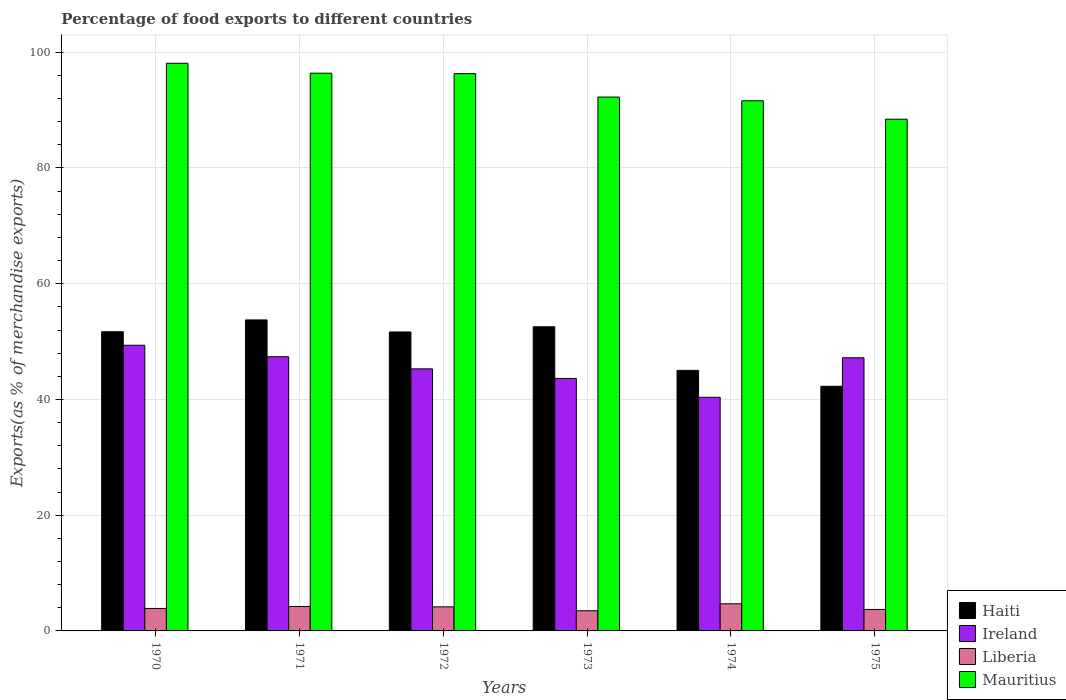How many groups of bars are there?
Offer a very short reply. 6. How many bars are there on the 2nd tick from the left?
Your answer should be compact. 4. How many bars are there on the 5th tick from the right?
Give a very brief answer. 4. What is the label of the 5th group of bars from the left?
Ensure brevity in your answer.  1974. What is the percentage of exports to different countries in Liberia in 1973?
Your response must be concise. 3.49. Across all years, what is the maximum percentage of exports to different countries in Mauritius?
Provide a short and direct response. 98.1. Across all years, what is the minimum percentage of exports to different countries in Ireland?
Your response must be concise. 40.37. In which year was the percentage of exports to different countries in Haiti maximum?
Your answer should be very brief. 1971. In which year was the percentage of exports to different countries in Mauritius minimum?
Offer a very short reply. 1975. What is the total percentage of exports to different countries in Ireland in the graph?
Ensure brevity in your answer.  273.23. What is the difference between the percentage of exports to different countries in Haiti in 1971 and that in 1974?
Give a very brief answer. 8.72. What is the difference between the percentage of exports to different countries in Mauritius in 1975 and the percentage of exports to different countries in Ireland in 1974?
Keep it short and to the point. 48.06. What is the average percentage of exports to different countries in Liberia per year?
Keep it short and to the point. 4.03. In the year 1975, what is the difference between the percentage of exports to different countries in Mauritius and percentage of exports to different countries in Liberia?
Your response must be concise. 84.72. What is the ratio of the percentage of exports to different countries in Haiti in 1971 to that in 1972?
Keep it short and to the point. 1.04. Is the percentage of exports to different countries in Liberia in 1970 less than that in 1972?
Provide a short and direct response. Yes. What is the difference between the highest and the second highest percentage of exports to different countries in Liberia?
Ensure brevity in your answer.  0.46. What is the difference between the highest and the lowest percentage of exports to different countries in Ireland?
Your response must be concise. 9. In how many years, is the percentage of exports to different countries in Liberia greater than the average percentage of exports to different countries in Liberia taken over all years?
Provide a succinct answer. 3. Is the sum of the percentage of exports to different countries in Liberia in 1971 and 1972 greater than the maximum percentage of exports to different countries in Mauritius across all years?
Offer a very short reply. No. What does the 3rd bar from the left in 1972 represents?
Offer a terse response. Liberia. What does the 2nd bar from the right in 1974 represents?
Offer a very short reply. Liberia. How many bars are there?
Your answer should be compact. 24. Are all the bars in the graph horizontal?
Keep it short and to the point. No. Are the values on the major ticks of Y-axis written in scientific E-notation?
Your answer should be very brief. No. Does the graph contain grids?
Provide a succinct answer. Yes. What is the title of the graph?
Offer a very short reply. Percentage of food exports to different countries. What is the label or title of the Y-axis?
Ensure brevity in your answer.  Exports(as % of merchandise exports). What is the Exports(as % of merchandise exports) in Haiti in 1970?
Your response must be concise. 51.71. What is the Exports(as % of merchandise exports) in Ireland in 1970?
Provide a short and direct response. 49.37. What is the Exports(as % of merchandise exports) in Liberia in 1970?
Ensure brevity in your answer.  3.88. What is the Exports(as % of merchandise exports) in Mauritius in 1970?
Offer a terse response. 98.1. What is the Exports(as % of merchandise exports) of Haiti in 1971?
Ensure brevity in your answer.  53.74. What is the Exports(as % of merchandise exports) in Ireland in 1971?
Offer a very short reply. 47.38. What is the Exports(as % of merchandise exports) in Liberia in 1971?
Ensure brevity in your answer.  4.22. What is the Exports(as % of merchandise exports) in Mauritius in 1971?
Offer a terse response. 96.38. What is the Exports(as % of merchandise exports) of Haiti in 1972?
Your response must be concise. 51.66. What is the Exports(as % of merchandise exports) in Ireland in 1972?
Offer a terse response. 45.29. What is the Exports(as % of merchandise exports) in Liberia in 1972?
Keep it short and to the point. 4.16. What is the Exports(as % of merchandise exports) in Mauritius in 1972?
Ensure brevity in your answer.  96.3. What is the Exports(as % of merchandise exports) in Haiti in 1973?
Offer a very short reply. 52.56. What is the Exports(as % of merchandise exports) of Ireland in 1973?
Provide a succinct answer. 43.63. What is the Exports(as % of merchandise exports) in Liberia in 1973?
Offer a very short reply. 3.49. What is the Exports(as % of merchandise exports) of Mauritius in 1973?
Provide a short and direct response. 92.26. What is the Exports(as % of merchandise exports) in Haiti in 1974?
Keep it short and to the point. 45.02. What is the Exports(as % of merchandise exports) of Ireland in 1974?
Your answer should be very brief. 40.37. What is the Exports(as % of merchandise exports) in Liberia in 1974?
Keep it short and to the point. 4.69. What is the Exports(as % of merchandise exports) of Mauritius in 1974?
Offer a terse response. 91.61. What is the Exports(as % of merchandise exports) of Haiti in 1975?
Provide a short and direct response. 42.28. What is the Exports(as % of merchandise exports) in Ireland in 1975?
Your answer should be very brief. 47.2. What is the Exports(as % of merchandise exports) in Liberia in 1975?
Offer a terse response. 3.71. What is the Exports(as % of merchandise exports) in Mauritius in 1975?
Keep it short and to the point. 88.43. Across all years, what is the maximum Exports(as % of merchandise exports) in Haiti?
Offer a terse response. 53.74. Across all years, what is the maximum Exports(as % of merchandise exports) in Ireland?
Offer a terse response. 49.37. Across all years, what is the maximum Exports(as % of merchandise exports) of Liberia?
Your response must be concise. 4.69. Across all years, what is the maximum Exports(as % of merchandise exports) in Mauritius?
Your response must be concise. 98.1. Across all years, what is the minimum Exports(as % of merchandise exports) of Haiti?
Make the answer very short. 42.28. Across all years, what is the minimum Exports(as % of merchandise exports) in Ireland?
Provide a succinct answer. 40.37. Across all years, what is the minimum Exports(as % of merchandise exports) of Liberia?
Offer a terse response. 3.49. Across all years, what is the minimum Exports(as % of merchandise exports) of Mauritius?
Keep it short and to the point. 88.43. What is the total Exports(as % of merchandise exports) of Haiti in the graph?
Your answer should be compact. 296.97. What is the total Exports(as % of merchandise exports) of Ireland in the graph?
Make the answer very short. 273.23. What is the total Exports(as % of merchandise exports) of Liberia in the graph?
Ensure brevity in your answer.  24.15. What is the total Exports(as % of merchandise exports) of Mauritius in the graph?
Give a very brief answer. 563.09. What is the difference between the Exports(as % of merchandise exports) of Haiti in 1970 and that in 1971?
Ensure brevity in your answer.  -2.04. What is the difference between the Exports(as % of merchandise exports) of Ireland in 1970 and that in 1971?
Provide a succinct answer. 1.99. What is the difference between the Exports(as % of merchandise exports) in Liberia in 1970 and that in 1971?
Your response must be concise. -0.34. What is the difference between the Exports(as % of merchandise exports) of Mauritius in 1970 and that in 1971?
Your answer should be compact. 1.72. What is the difference between the Exports(as % of merchandise exports) of Haiti in 1970 and that in 1972?
Keep it short and to the point. 0.04. What is the difference between the Exports(as % of merchandise exports) in Ireland in 1970 and that in 1972?
Keep it short and to the point. 4.08. What is the difference between the Exports(as % of merchandise exports) in Liberia in 1970 and that in 1972?
Your response must be concise. -0.27. What is the difference between the Exports(as % of merchandise exports) in Mauritius in 1970 and that in 1972?
Ensure brevity in your answer.  1.79. What is the difference between the Exports(as % of merchandise exports) of Haiti in 1970 and that in 1973?
Your response must be concise. -0.85. What is the difference between the Exports(as % of merchandise exports) of Ireland in 1970 and that in 1973?
Your answer should be compact. 5.74. What is the difference between the Exports(as % of merchandise exports) in Liberia in 1970 and that in 1973?
Offer a terse response. 0.4. What is the difference between the Exports(as % of merchandise exports) of Mauritius in 1970 and that in 1973?
Your answer should be very brief. 5.84. What is the difference between the Exports(as % of merchandise exports) of Haiti in 1970 and that in 1974?
Your response must be concise. 6.68. What is the difference between the Exports(as % of merchandise exports) of Ireland in 1970 and that in 1974?
Ensure brevity in your answer.  9. What is the difference between the Exports(as % of merchandise exports) of Liberia in 1970 and that in 1974?
Give a very brief answer. -0.8. What is the difference between the Exports(as % of merchandise exports) of Mauritius in 1970 and that in 1974?
Keep it short and to the point. 6.49. What is the difference between the Exports(as % of merchandise exports) of Haiti in 1970 and that in 1975?
Ensure brevity in your answer.  9.43. What is the difference between the Exports(as % of merchandise exports) in Ireland in 1970 and that in 1975?
Offer a very short reply. 2.17. What is the difference between the Exports(as % of merchandise exports) in Liberia in 1970 and that in 1975?
Your answer should be very brief. 0.17. What is the difference between the Exports(as % of merchandise exports) in Mauritius in 1970 and that in 1975?
Ensure brevity in your answer.  9.67. What is the difference between the Exports(as % of merchandise exports) of Haiti in 1971 and that in 1972?
Ensure brevity in your answer.  2.08. What is the difference between the Exports(as % of merchandise exports) in Ireland in 1971 and that in 1972?
Your answer should be compact. 2.09. What is the difference between the Exports(as % of merchandise exports) of Liberia in 1971 and that in 1972?
Your answer should be very brief. 0.07. What is the difference between the Exports(as % of merchandise exports) of Mauritius in 1971 and that in 1972?
Offer a very short reply. 0.08. What is the difference between the Exports(as % of merchandise exports) of Haiti in 1971 and that in 1973?
Ensure brevity in your answer.  1.18. What is the difference between the Exports(as % of merchandise exports) in Ireland in 1971 and that in 1973?
Provide a succinct answer. 3.75. What is the difference between the Exports(as % of merchandise exports) in Liberia in 1971 and that in 1973?
Provide a short and direct response. 0.74. What is the difference between the Exports(as % of merchandise exports) in Mauritius in 1971 and that in 1973?
Your answer should be very brief. 4.12. What is the difference between the Exports(as % of merchandise exports) in Haiti in 1971 and that in 1974?
Your answer should be compact. 8.72. What is the difference between the Exports(as % of merchandise exports) in Ireland in 1971 and that in 1974?
Your answer should be very brief. 7. What is the difference between the Exports(as % of merchandise exports) of Liberia in 1971 and that in 1974?
Your answer should be very brief. -0.46. What is the difference between the Exports(as % of merchandise exports) in Mauritius in 1971 and that in 1974?
Offer a terse response. 4.77. What is the difference between the Exports(as % of merchandise exports) in Haiti in 1971 and that in 1975?
Keep it short and to the point. 11.46. What is the difference between the Exports(as % of merchandise exports) of Ireland in 1971 and that in 1975?
Your response must be concise. 0.18. What is the difference between the Exports(as % of merchandise exports) of Liberia in 1971 and that in 1975?
Ensure brevity in your answer.  0.51. What is the difference between the Exports(as % of merchandise exports) of Mauritius in 1971 and that in 1975?
Keep it short and to the point. 7.95. What is the difference between the Exports(as % of merchandise exports) of Haiti in 1972 and that in 1973?
Provide a short and direct response. -0.89. What is the difference between the Exports(as % of merchandise exports) in Ireland in 1972 and that in 1973?
Your answer should be very brief. 1.66. What is the difference between the Exports(as % of merchandise exports) of Liberia in 1972 and that in 1973?
Offer a very short reply. 0.67. What is the difference between the Exports(as % of merchandise exports) of Mauritius in 1972 and that in 1973?
Your answer should be very brief. 4.05. What is the difference between the Exports(as % of merchandise exports) of Haiti in 1972 and that in 1974?
Ensure brevity in your answer.  6.64. What is the difference between the Exports(as % of merchandise exports) of Ireland in 1972 and that in 1974?
Make the answer very short. 4.91. What is the difference between the Exports(as % of merchandise exports) in Liberia in 1972 and that in 1974?
Provide a succinct answer. -0.53. What is the difference between the Exports(as % of merchandise exports) of Mauritius in 1972 and that in 1974?
Offer a terse response. 4.69. What is the difference between the Exports(as % of merchandise exports) of Haiti in 1972 and that in 1975?
Your answer should be compact. 9.39. What is the difference between the Exports(as % of merchandise exports) in Ireland in 1972 and that in 1975?
Provide a succinct answer. -1.91. What is the difference between the Exports(as % of merchandise exports) in Liberia in 1972 and that in 1975?
Keep it short and to the point. 0.45. What is the difference between the Exports(as % of merchandise exports) in Mauritius in 1972 and that in 1975?
Provide a succinct answer. 7.87. What is the difference between the Exports(as % of merchandise exports) of Haiti in 1973 and that in 1974?
Give a very brief answer. 7.53. What is the difference between the Exports(as % of merchandise exports) of Ireland in 1973 and that in 1974?
Give a very brief answer. 3.25. What is the difference between the Exports(as % of merchandise exports) in Liberia in 1973 and that in 1974?
Provide a short and direct response. -1.2. What is the difference between the Exports(as % of merchandise exports) of Mauritius in 1973 and that in 1974?
Ensure brevity in your answer.  0.65. What is the difference between the Exports(as % of merchandise exports) of Haiti in 1973 and that in 1975?
Your answer should be very brief. 10.28. What is the difference between the Exports(as % of merchandise exports) in Ireland in 1973 and that in 1975?
Give a very brief answer. -3.57. What is the difference between the Exports(as % of merchandise exports) in Liberia in 1973 and that in 1975?
Your response must be concise. -0.22. What is the difference between the Exports(as % of merchandise exports) of Mauritius in 1973 and that in 1975?
Provide a succinct answer. 3.83. What is the difference between the Exports(as % of merchandise exports) of Haiti in 1974 and that in 1975?
Offer a very short reply. 2.75. What is the difference between the Exports(as % of merchandise exports) in Ireland in 1974 and that in 1975?
Provide a short and direct response. -6.83. What is the difference between the Exports(as % of merchandise exports) of Liberia in 1974 and that in 1975?
Your answer should be very brief. 0.97. What is the difference between the Exports(as % of merchandise exports) in Mauritius in 1974 and that in 1975?
Ensure brevity in your answer.  3.18. What is the difference between the Exports(as % of merchandise exports) in Haiti in 1970 and the Exports(as % of merchandise exports) in Ireland in 1971?
Your response must be concise. 4.33. What is the difference between the Exports(as % of merchandise exports) of Haiti in 1970 and the Exports(as % of merchandise exports) of Liberia in 1971?
Your response must be concise. 47.48. What is the difference between the Exports(as % of merchandise exports) in Haiti in 1970 and the Exports(as % of merchandise exports) in Mauritius in 1971?
Provide a succinct answer. -44.68. What is the difference between the Exports(as % of merchandise exports) of Ireland in 1970 and the Exports(as % of merchandise exports) of Liberia in 1971?
Your answer should be compact. 45.14. What is the difference between the Exports(as % of merchandise exports) of Ireland in 1970 and the Exports(as % of merchandise exports) of Mauritius in 1971?
Ensure brevity in your answer.  -47.01. What is the difference between the Exports(as % of merchandise exports) of Liberia in 1970 and the Exports(as % of merchandise exports) of Mauritius in 1971?
Make the answer very short. -92.5. What is the difference between the Exports(as % of merchandise exports) in Haiti in 1970 and the Exports(as % of merchandise exports) in Ireland in 1972?
Keep it short and to the point. 6.42. What is the difference between the Exports(as % of merchandise exports) of Haiti in 1970 and the Exports(as % of merchandise exports) of Liberia in 1972?
Keep it short and to the point. 47.55. What is the difference between the Exports(as % of merchandise exports) of Haiti in 1970 and the Exports(as % of merchandise exports) of Mauritius in 1972?
Offer a very short reply. -44.6. What is the difference between the Exports(as % of merchandise exports) in Ireland in 1970 and the Exports(as % of merchandise exports) in Liberia in 1972?
Provide a succinct answer. 45.21. What is the difference between the Exports(as % of merchandise exports) in Ireland in 1970 and the Exports(as % of merchandise exports) in Mauritius in 1972?
Offer a terse response. -46.94. What is the difference between the Exports(as % of merchandise exports) of Liberia in 1970 and the Exports(as % of merchandise exports) of Mauritius in 1972?
Offer a terse response. -92.42. What is the difference between the Exports(as % of merchandise exports) of Haiti in 1970 and the Exports(as % of merchandise exports) of Ireland in 1973?
Keep it short and to the point. 8.08. What is the difference between the Exports(as % of merchandise exports) in Haiti in 1970 and the Exports(as % of merchandise exports) in Liberia in 1973?
Ensure brevity in your answer.  48.22. What is the difference between the Exports(as % of merchandise exports) of Haiti in 1970 and the Exports(as % of merchandise exports) of Mauritius in 1973?
Your response must be concise. -40.55. What is the difference between the Exports(as % of merchandise exports) in Ireland in 1970 and the Exports(as % of merchandise exports) in Liberia in 1973?
Keep it short and to the point. 45.88. What is the difference between the Exports(as % of merchandise exports) in Ireland in 1970 and the Exports(as % of merchandise exports) in Mauritius in 1973?
Offer a very short reply. -42.89. What is the difference between the Exports(as % of merchandise exports) in Liberia in 1970 and the Exports(as % of merchandise exports) in Mauritius in 1973?
Your answer should be compact. -88.37. What is the difference between the Exports(as % of merchandise exports) of Haiti in 1970 and the Exports(as % of merchandise exports) of Ireland in 1974?
Offer a terse response. 11.33. What is the difference between the Exports(as % of merchandise exports) in Haiti in 1970 and the Exports(as % of merchandise exports) in Liberia in 1974?
Provide a succinct answer. 47.02. What is the difference between the Exports(as % of merchandise exports) of Haiti in 1970 and the Exports(as % of merchandise exports) of Mauritius in 1974?
Offer a terse response. -39.91. What is the difference between the Exports(as % of merchandise exports) of Ireland in 1970 and the Exports(as % of merchandise exports) of Liberia in 1974?
Your answer should be compact. 44.68. What is the difference between the Exports(as % of merchandise exports) in Ireland in 1970 and the Exports(as % of merchandise exports) in Mauritius in 1974?
Your response must be concise. -42.25. What is the difference between the Exports(as % of merchandise exports) of Liberia in 1970 and the Exports(as % of merchandise exports) of Mauritius in 1974?
Make the answer very short. -87.73. What is the difference between the Exports(as % of merchandise exports) of Haiti in 1970 and the Exports(as % of merchandise exports) of Ireland in 1975?
Provide a succinct answer. 4.51. What is the difference between the Exports(as % of merchandise exports) in Haiti in 1970 and the Exports(as % of merchandise exports) in Liberia in 1975?
Offer a terse response. 47.99. What is the difference between the Exports(as % of merchandise exports) of Haiti in 1970 and the Exports(as % of merchandise exports) of Mauritius in 1975?
Provide a succinct answer. -36.73. What is the difference between the Exports(as % of merchandise exports) of Ireland in 1970 and the Exports(as % of merchandise exports) of Liberia in 1975?
Make the answer very short. 45.66. What is the difference between the Exports(as % of merchandise exports) of Ireland in 1970 and the Exports(as % of merchandise exports) of Mauritius in 1975?
Make the answer very short. -39.06. What is the difference between the Exports(as % of merchandise exports) in Liberia in 1970 and the Exports(as % of merchandise exports) in Mauritius in 1975?
Give a very brief answer. -84.55. What is the difference between the Exports(as % of merchandise exports) of Haiti in 1971 and the Exports(as % of merchandise exports) of Ireland in 1972?
Give a very brief answer. 8.46. What is the difference between the Exports(as % of merchandise exports) of Haiti in 1971 and the Exports(as % of merchandise exports) of Liberia in 1972?
Provide a succinct answer. 49.58. What is the difference between the Exports(as % of merchandise exports) of Haiti in 1971 and the Exports(as % of merchandise exports) of Mauritius in 1972?
Provide a short and direct response. -42.56. What is the difference between the Exports(as % of merchandise exports) of Ireland in 1971 and the Exports(as % of merchandise exports) of Liberia in 1972?
Provide a short and direct response. 43.22. What is the difference between the Exports(as % of merchandise exports) of Ireland in 1971 and the Exports(as % of merchandise exports) of Mauritius in 1972?
Offer a very short reply. -48.93. What is the difference between the Exports(as % of merchandise exports) of Liberia in 1971 and the Exports(as % of merchandise exports) of Mauritius in 1972?
Offer a very short reply. -92.08. What is the difference between the Exports(as % of merchandise exports) in Haiti in 1971 and the Exports(as % of merchandise exports) in Ireland in 1973?
Your answer should be compact. 10.12. What is the difference between the Exports(as % of merchandise exports) of Haiti in 1971 and the Exports(as % of merchandise exports) of Liberia in 1973?
Provide a succinct answer. 50.26. What is the difference between the Exports(as % of merchandise exports) of Haiti in 1971 and the Exports(as % of merchandise exports) of Mauritius in 1973?
Your response must be concise. -38.52. What is the difference between the Exports(as % of merchandise exports) of Ireland in 1971 and the Exports(as % of merchandise exports) of Liberia in 1973?
Give a very brief answer. 43.89. What is the difference between the Exports(as % of merchandise exports) of Ireland in 1971 and the Exports(as % of merchandise exports) of Mauritius in 1973?
Make the answer very short. -44.88. What is the difference between the Exports(as % of merchandise exports) in Liberia in 1971 and the Exports(as % of merchandise exports) in Mauritius in 1973?
Your response must be concise. -88.03. What is the difference between the Exports(as % of merchandise exports) in Haiti in 1971 and the Exports(as % of merchandise exports) in Ireland in 1974?
Keep it short and to the point. 13.37. What is the difference between the Exports(as % of merchandise exports) in Haiti in 1971 and the Exports(as % of merchandise exports) in Liberia in 1974?
Your answer should be very brief. 49.06. What is the difference between the Exports(as % of merchandise exports) of Haiti in 1971 and the Exports(as % of merchandise exports) of Mauritius in 1974?
Make the answer very short. -37.87. What is the difference between the Exports(as % of merchandise exports) of Ireland in 1971 and the Exports(as % of merchandise exports) of Liberia in 1974?
Make the answer very short. 42.69. What is the difference between the Exports(as % of merchandise exports) of Ireland in 1971 and the Exports(as % of merchandise exports) of Mauritius in 1974?
Offer a very short reply. -44.24. What is the difference between the Exports(as % of merchandise exports) of Liberia in 1971 and the Exports(as % of merchandise exports) of Mauritius in 1974?
Your response must be concise. -87.39. What is the difference between the Exports(as % of merchandise exports) in Haiti in 1971 and the Exports(as % of merchandise exports) in Ireland in 1975?
Keep it short and to the point. 6.54. What is the difference between the Exports(as % of merchandise exports) in Haiti in 1971 and the Exports(as % of merchandise exports) in Liberia in 1975?
Keep it short and to the point. 50.03. What is the difference between the Exports(as % of merchandise exports) of Haiti in 1971 and the Exports(as % of merchandise exports) of Mauritius in 1975?
Your answer should be very brief. -34.69. What is the difference between the Exports(as % of merchandise exports) in Ireland in 1971 and the Exports(as % of merchandise exports) in Liberia in 1975?
Make the answer very short. 43.67. What is the difference between the Exports(as % of merchandise exports) of Ireland in 1971 and the Exports(as % of merchandise exports) of Mauritius in 1975?
Give a very brief answer. -41.05. What is the difference between the Exports(as % of merchandise exports) in Liberia in 1971 and the Exports(as % of merchandise exports) in Mauritius in 1975?
Your response must be concise. -84.21. What is the difference between the Exports(as % of merchandise exports) in Haiti in 1972 and the Exports(as % of merchandise exports) in Ireland in 1973?
Provide a short and direct response. 8.04. What is the difference between the Exports(as % of merchandise exports) of Haiti in 1972 and the Exports(as % of merchandise exports) of Liberia in 1973?
Offer a very short reply. 48.18. What is the difference between the Exports(as % of merchandise exports) of Haiti in 1972 and the Exports(as % of merchandise exports) of Mauritius in 1973?
Provide a short and direct response. -40.59. What is the difference between the Exports(as % of merchandise exports) of Ireland in 1972 and the Exports(as % of merchandise exports) of Liberia in 1973?
Make the answer very short. 41.8. What is the difference between the Exports(as % of merchandise exports) of Ireland in 1972 and the Exports(as % of merchandise exports) of Mauritius in 1973?
Keep it short and to the point. -46.97. What is the difference between the Exports(as % of merchandise exports) in Liberia in 1972 and the Exports(as % of merchandise exports) in Mauritius in 1973?
Your answer should be very brief. -88.1. What is the difference between the Exports(as % of merchandise exports) in Haiti in 1972 and the Exports(as % of merchandise exports) in Ireland in 1974?
Your response must be concise. 11.29. What is the difference between the Exports(as % of merchandise exports) in Haiti in 1972 and the Exports(as % of merchandise exports) in Liberia in 1974?
Your response must be concise. 46.98. What is the difference between the Exports(as % of merchandise exports) in Haiti in 1972 and the Exports(as % of merchandise exports) in Mauritius in 1974?
Provide a succinct answer. -39.95. What is the difference between the Exports(as % of merchandise exports) in Ireland in 1972 and the Exports(as % of merchandise exports) in Liberia in 1974?
Your answer should be compact. 40.6. What is the difference between the Exports(as % of merchandise exports) of Ireland in 1972 and the Exports(as % of merchandise exports) of Mauritius in 1974?
Provide a succinct answer. -46.33. What is the difference between the Exports(as % of merchandise exports) of Liberia in 1972 and the Exports(as % of merchandise exports) of Mauritius in 1974?
Ensure brevity in your answer.  -87.45. What is the difference between the Exports(as % of merchandise exports) in Haiti in 1972 and the Exports(as % of merchandise exports) in Ireland in 1975?
Your answer should be very brief. 4.47. What is the difference between the Exports(as % of merchandise exports) in Haiti in 1972 and the Exports(as % of merchandise exports) in Liberia in 1975?
Provide a short and direct response. 47.95. What is the difference between the Exports(as % of merchandise exports) of Haiti in 1972 and the Exports(as % of merchandise exports) of Mauritius in 1975?
Give a very brief answer. -36.77. What is the difference between the Exports(as % of merchandise exports) of Ireland in 1972 and the Exports(as % of merchandise exports) of Liberia in 1975?
Give a very brief answer. 41.57. What is the difference between the Exports(as % of merchandise exports) of Ireland in 1972 and the Exports(as % of merchandise exports) of Mauritius in 1975?
Ensure brevity in your answer.  -43.15. What is the difference between the Exports(as % of merchandise exports) in Liberia in 1972 and the Exports(as % of merchandise exports) in Mauritius in 1975?
Keep it short and to the point. -84.27. What is the difference between the Exports(as % of merchandise exports) of Haiti in 1973 and the Exports(as % of merchandise exports) of Ireland in 1974?
Give a very brief answer. 12.19. What is the difference between the Exports(as % of merchandise exports) in Haiti in 1973 and the Exports(as % of merchandise exports) in Liberia in 1974?
Offer a terse response. 47.87. What is the difference between the Exports(as % of merchandise exports) of Haiti in 1973 and the Exports(as % of merchandise exports) of Mauritius in 1974?
Give a very brief answer. -39.05. What is the difference between the Exports(as % of merchandise exports) in Ireland in 1973 and the Exports(as % of merchandise exports) in Liberia in 1974?
Make the answer very short. 38.94. What is the difference between the Exports(as % of merchandise exports) of Ireland in 1973 and the Exports(as % of merchandise exports) of Mauritius in 1974?
Keep it short and to the point. -47.99. What is the difference between the Exports(as % of merchandise exports) in Liberia in 1973 and the Exports(as % of merchandise exports) in Mauritius in 1974?
Offer a terse response. -88.13. What is the difference between the Exports(as % of merchandise exports) in Haiti in 1973 and the Exports(as % of merchandise exports) in Ireland in 1975?
Keep it short and to the point. 5.36. What is the difference between the Exports(as % of merchandise exports) in Haiti in 1973 and the Exports(as % of merchandise exports) in Liberia in 1975?
Your answer should be compact. 48.85. What is the difference between the Exports(as % of merchandise exports) of Haiti in 1973 and the Exports(as % of merchandise exports) of Mauritius in 1975?
Your answer should be compact. -35.87. What is the difference between the Exports(as % of merchandise exports) in Ireland in 1973 and the Exports(as % of merchandise exports) in Liberia in 1975?
Provide a short and direct response. 39.92. What is the difference between the Exports(as % of merchandise exports) of Ireland in 1973 and the Exports(as % of merchandise exports) of Mauritius in 1975?
Ensure brevity in your answer.  -44.8. What is the difference between the Exports(as % of merchandise exports) of Liberia in 1973 and the Exports(as % of merchandise exports) of Mauritius in 1975?
Keep it short and to the point. -84.94. What is the difference between the Exports(as % of merchandise exports) in Haiti in 1974 and the Exports(as % of merchandise exports) in Ireland in 1975?
Ensure brevity in your answer.  -2.17. What is the difference between the Exports(as % of merchandise exports) in Haiti in 1974 and the Exports(as % of merchandise exports) in Liberia in 1975?
Make the answer very short. 41.31. What is the difference between the Exports(as % of merchandise exports) in Haiti in 1974 and the Exports(as % of merchandise exports) in Mauritius in 1975?
Offer a very short reply. -43.41. What is the difference between the Exports(as % of merchandise exports) of Ireland in 1974 and the Exports(as % of merchandise exports) of Liberia in 1975?
Your response must be concise. 36.66. What is the difference between the Exports(as % of merchandise exports) in Ireland in 1974 and the Exports(as % of merchandise exports) in Mauritius in 1975?
Offer a terse response. -48.06. What is the difference between the Exports(as % of merchandise exports) of Liberia in 1974 and the Exports(as % of merchandise exports) of Mauritius in 1975?
Offer a very short reply. -83.75. What is the average Exports(as % of merchandise exports) of Haiti per year?
Keep it short and to the point. 49.5. What is the average Exports(as % of merchandise exports) of Ireland per year?
Give a very brief answer. 45.54. What is the average Exports(as % of merchandise exports) of Liberia per year?
Your answer should be compact. 4.03. What is the average Exports(as % of merchandise exports) of Mauritius per year?
Make the answer very short. 93.85. In the year 1970, what is the difference between the Exports(as % of merchandise exports) of Haiti and Exports(as % of merchandise exports) of Ireland?
Your response must be concise. 2.34. In the year 1970, what is the difference between the Exports(as % of merchandise exports) of Haiti and Exports(as % of merchandise exports) of Liberia?
Keep it short and to the point. 47.82. In the year 1970, what is the difference between the Exports(as % of merchandise exports) in Haiti and Exports(as % of merchandise exports) in Mauritius?
Your answer should be compact. -46.39. In the year 1970, what is the difference between the Exports(as % of merchandise exports) of Ireland and Exports(as % of merchandise exports) of Liberia?
Your answer should be very brief. 45.48. In the year 1970, what is the difference between the Exports(as % of merchandise exports) of Ireland and Exports(as % of merchandise exports) of Mauritius?
Offer a very short reply. -48.73. In the year 1970, what is the difference between the Exports(as % of merchandise exports) in Liberia and Exports(as % of merchandise exports) in Mauritius?
Your answer should be very brief. -94.21. In the year 1971, what is the difference between the Exports(as % of merchandise exports) in Haiti and Exports(as % of merchandise exports) in Ireland?
Your response must be concise. 6.37. In the year 1971, what is the difference between the Exports(as % of merchandise exports) of Haiti and Exports(as % of merchandise exports) of Liberia?
Offer a terse response. 49.52. In the year 1971, what is the difference between the Exports(as % of merchandise exports) of Haiti and Exports(as % of merchandise exports) of Mauritius?
Offer a very short reply. -42.64. In the year 1971, what is the difference between the Exports(as % of merchandise exports) in Ireland and Exports(as % of merchandise exports) in Liberia?
Offer a very short reply. 43.15. In the year 1971, what is the difference between the Exports(as % of merchandise exports) in Ireland and Exports(as % of merchandise exports) in Mauritius?
Provide a succinct answer. -49.01. In the year 1971, what is the difference between the Exports(as % of merchandise exports) in Liberia and Exports(as % of merchandise exports) in Mauritius?
Keep it short and to the point. -92.16. In the year 1972, what is the difference between the Exports(as % of merchandise exports) in Haiti and Exports(as % of merchandise exports) in Ireland?
Give a very brief answer. 6.38. In the year 1972, what is the difference between the Exports(as % of merchandise exports) in Haiti and Exports(as % of merchandise exports) in Liberia?
Provide a short and direct response. 47.51. In the year 1972, what is the difference between the Exports(as % of merchandise exports) of Haiti and Exports(as % of merchandise exports) of Mauritius?
Offer a terse response. -44.64. In the year 1972, what is the difference between the Exports(as % of merchandise exports) in Ireland and Exports(as % of merchandise exports) in Liberia?
Keep it short and to the point. 41.13. In the year 1972, what is the difference between the Exports(as % of merchandise exports) of Ireland and Exports(as % of merchandise exports) of Mauritius?
Your response must be concise. -51.02. In the year 1972, what is the difference between the Exports(as % of merchandise exports) in Liberia and Exports(as % of merchandise exports) in Mauritius?
Provide a succinct answer. -92.14. In the year 1973, what is the difference between the Exports(as % of merchandise exports) of Haiti and Exports(as % of merchandise exports) of Ireland?
Provide a succinct answer. 8.93. In the year 1973, what is the difference between the Exports(as % of merchandise exports) of Haiti and Exports(as % of merchandise exports) of Liberia?
Make the answer very short. 49.07. In the year 1973, what is the difference between the Exports(as % of merchandise exports) of Haiti and Exports(as % of merchandise exports) of Mauritius?
Keep it short and to the point. -39.7. In the year 1973, what is the difference between the Exports(as % of merchandise exports) of Ireland and Exports(as % of merchandise exports) of Liberia?
Keep it short and to the point. 40.14. In the year 1973, what is the difference between the Exports(as % of merchandise exports) in Ireland and Exports(as % of merchandise exports) in Mauritius?
Ensure brevity in your answer.  -48.63. In the year 1973, what is the difference between the Exports(as % of merchandise exports) of Liberia and Exports(as % of merchandise exports) of Mauritius?
Offer a very short reply. -88.77. In the year 1974, what is the difference between the Exports(as % of merchandise exports) in Haiti and Exports(as % of merchandise exports) in Ireland?
Make the answer very short. 4.65. In the year 1974, what is the difference between the Exports(as % of merchandise exports) of Haiti and Exports(as % of merchandise exports) of Liberia?
Your answer should be compact. 40.34. In the year 1974, what is the difference between the Exports(as % of merchandise exports) of Haiti and Exports(as % of merchandise exports) of Mauritius?
Your answer should be very brief. -46.59. In the year 1974, what is the difference between the Exports(as % of merchandise exports) in Ireland and Exports(as % of merchandise exports) in Liberia?
Offer a terse response. 35.69. In the year 1974, what is the difference between the Exports(as % of merchandise exports) of Ireland and Exports(as % of merchandise exports) of Mauritius?
Keep it short and to the point. -51.24. In the year 1974, what is the difference between the Exports(as % of merchandise exports) of Liberia and Exports(as % of merchandise exports) of Mauritius?
Ensure brevity in your answer.  -86.93. In the year 1975, what is the difference between the Exports(as % of merchandise exports) in Haiti and Exports(as % of merchandise exports) in Ireland?
Offer a very short reply. -4.92. In the year 1975, what is the difference between the Exports(as % of merchandise exports) in Haiti and Exports(as % of merchandise exports) in Liberia?
Make the answer very short. 38.57. In the year 1975, what is the difference between the Exports(as % of merchandise exports) in Haiti and Exports(as % of merchandise exports) in Mauritius?
Make the answer very short. -46.15. In the year 1975, what is the difference between the Exports(as % of merchandise exports) of Ireland and Exports(as % of merchandise exports) of Liberia?
Offer a terse response. 43.49. In the year 1975, what is the difference between the Exports(as % of merchandise exports) of Ireland and Exports(as % of merchandise exports) of Mauritius?
Provide a succinct answer. -41.23. In the year 1975, what is the difference between the Exports(as % of merchandise exports) of Liberia and Exports(as % of merchandise exports) of Mauritius?
Give a very brief answer. -84.72. What is the ratio of the Exports(as % of merchandise exports) of Haiti in 1970 to that in 1971?
Offer a very short reply. 0.96. What is the ratio of the Exports(as % of merchandise exports) of Ireland in 1970 to that in 1971?
Provide a short and direct response. 1.04. What is the ratio of the Exports(as % of merchandise exports) in Liberia in 1970 to that in 1971?
Your answer should be very brief. 0.92. What is the ratio of the Exports(as % of merchandise exports) of Mauritius in 1970 to that in 1971?
Your answer should be very brief. 1.02. What is the ratio of the Exports(as % of merchandise exports) of Haiti in 1970 to that in 1972?
Ensure brevity in your answer.  1. What is the ratio of the Exports(as % of merchandise exports) of Ireland in 1970 to that in 1972?
Your answer should be very brief. 1.09. What is the ratio of the Exports(as % of merchandise exports) of Liberia in 1970 to that in 1972?
Offer a very short reply. 0.93. What is the ratio of the Exports(as % of merchandise exports) of Mauritius in 1970 to that in 1972?
Provide a short and direct response. 1.02. What is the ratio of the Exports(as % of merchandise exports) in Haiti in 1970 to that in 1973?
Provide a succinct answer. 0.98. What is the ratio of the Exports(as % of merchandise exports) in Ireland in 1970 to that in 1973?
Your answer should be compact. 1.13. What is the ratio of the Exports(as % of merchandise exports) in Liberia in 1970 to that in 1973?
Offer a very short reply. 1.11. What is the ratio of the Exports(as % of merchandise exports) in Mauritius in 1970 to that in 1973?
Ensure brevity in your answer.  1.06. What is the ratio of the Exports(as % of merchandise exports) of Haiti in 1970 to that in 1974?
Provide a succinct answer. 1.15. What is the ratio of the Exports(as % of merchandise exports) in Ireland in 1970 to that in 1974?
Offer a very short reply. 1.22. What is the ratio of the Exports(as % of merchandise exports) of Liberia in 1970 to that in 1974?
Keep it short and to the point. 0.83. What is the ratio of the Exports(as % of merchandise exports) of Mauritius in 1970 to that in 1974?
Provide a short and direct response. 1.07. What is the ratio of the Exports(as % of merchandise exports) in Haiti in 1970 to that in 1975?
Your answer should be very brief. 1.22. What is the ratio of the Exports(as % of merchandise exports) in Ireland in 1970 to that in 1975?
Offer a terse response. 1.05. What is the ratio of the Exports(as % of merchandise exports) of Liberia in 1970 to that in 1975?
Give a very brief answer. 1.05. What is the ratio of the Exports(as % of merchandise exports) in Mauritius in 1970 to that in 1975?
Give a very brief answer. 1.11. What is the ratio of the Exports(as % of merchandise exports) in Haiti in 1971 to that in 1972?
Provide a succinct answer. 1.04. What is the ratio of the Exports(as % of merchandise exports) in Ireland in 1971 to that in 1972?
Keep it short and to the point. 1.05. What is the ratio of the Exports(as % of merchandise exports) in Liberia in 1971 to that in 1972?
Provide a succinct answer. 1.02. What is the ratio of the Exports(as % of merchandise exports) of Mauritius in 1971 to that in 1972?
Your answer should be very brief. 1. What is the ratio of the Exports(as % of merchandise exports) in Haiti in 1971 to that in 1973?
Offer a terse response. 1.02. What is the ratio of the Exports(as % of merchandise exports) of Ireland in 1971 to that in 1973?
Your answer should be compact. 1.09. What is the ratio of the Exports(as % of merchandise exports) in Liberia in 1971 to that in 1973?
Offer a terse response. 1.21. What is the ratio of the Exports(as % of merchandise exports) of Mauritius in 1971 to that in 1973?
Offer a very short reply. 1.04. What is the ratio of the Exports(as % of merchandise exports) of Haiti in 1971 to that in 1974?
Your response must be concise. 1.19. What is the ratio of the Exports(as % of merchandise exports) in Ireland in 1971 to that in 1974?
Keep it short and to the point. 1.17. What is the ratio of the Exports(as % of merchandise exports) of Liberia in 1971 to that in 1974?
Your response must be concise. 0.9. What is the ratio of the Exports(as % of merchandise exports) in Mauritius in 1971 to that in 1974?
Offer a very short reply. 1.05. What is the ratio of the Exports(as % of merchandise exports) in Haiti in 1971 to that in 1975?
Make the answer very short. 1.27. What is the ratio of the Exports(as % of merchandise exports) in Ireland in 1971 to that in 1975?
Your response must be concise. 1. What is the ratio of the Exports(as % of merchandise exports) of Liberia in 1971 to that in 1975?
Your answer should be compact. 1.14. What is the ratio of the Exports(as % of merchandise exports) in Mauritius in 1971 to that in 1975?
Provide a short and direct response. 1.09. What is the ratio of the Exports(as % of merchandise exports) in Haiti in 1972 to that in 1973?
Offer a terse response. 0.98. What is the ratio of the Exports(as % of merchandise exports) of Ireland in 1972 to that in 1973?
Offer a terse response. 1.04. What is the ratio of the Exports(as % of merchandise exports) in Liberia in 1972 to that in 1973?
Your response must be concise. 1.19. What is the ratio of the Exports(as % of merchandise exports) in Mauritius in 1972 to that in 1973?
Keep it short and to the point. 1.04. What is the ratio of the Exports(as % of merchandise exports) of Haiti in 1972 to that in 1974?
Your answer should be very brief. 1.15. What is the ratio of the Exports(as % of merchandise exports) of Ireland in 1972 to that in 1974?
Your answer should be compact. 1.12. What is the ratio of the Exports(as % of merchandise exports) in Liberia in 1972 to that in 1974?
Ensure brevity in your answer.  0.89. What is the ratio of the Exports(as % of merchandise exports) of Mauritius in 1972 to that in 1974?
Your answer should be compact. 1.05. What is the ratio of the Exports(as % of merchandise exports) of Haiti in 1972 to that in 1975?
Ensure brevity in your answer.  1.22. What is the ratio of the Exports(as % of merchandise exports) of Ireland in 1972 to that in 1975?
Give a very brief answer. 0.96. What is the ratio of the Exports(as % of merchandise exports) in Liberia in 1972 to that in 1975?
Offer a very short reply. 1.12. What is the ratio of the Exports(as % of merchandise exports) in Mauritius in 1972 to that in 1975?
Provide a short and direct response. 1.09. What is the ratio of the Exports(as % of merchandise exports) in Haiti in 1973 to that in 1974?
Make the answer very short. 1.17. What is the ratio of the Exports(as % of merchandise exports) of Ireland in 1973 to that in 1974?
Offer a very short reply. 1.08. What is the ratio of the Exports(as % of merchandise exports) of Liberia in 1973 to that in 1974?
Your response must be concise. 0.74. What is the ratio of the Exports(as % of merchandise exports) of Mauritius in 1973 to that in 1974?
Your answer should be very brief. 1.01. What is the ratio of the Exports(as % of merchandise exports) in Haiti in 1973 to that in 1975?
Keep it short and to the point. 1.24. What is the ratio of the Exports(as % of merchandise exports) of Ireland in 1973 to that in 1975?
Offer a terse response. 0.92. What is the ratio of the Exports(as % of merchandise exports) of Liberia in 1973 to that in 1975?
Offer a very short reply. 0.94. What is the ratio of the Exports(as % of merchandise exports) in Mauritius in 1973 to that in 1975?
Your response must be concise. 1.04. What is the ratio of the Exports(as % of merchandise exports) of Haiti in 1974 to that in 1975?
Your answer should be very brief. 1.06. What is the ratio of the Exports(as % of merchandise exports) of Ireland in 1974 to that in 1975?
Give a very brief answer. 0.86. What is the ratio of the Exports(as % of merchandise exports) of Liberia in 1974 to that in 1975?
Provide a short and direct response. 1.26. What is the ratio of the Exports(as % of merchandise exports) of Mauritius in 1974 to that in 1975?
Your answer should be very brief. 1.04. What is the difference between the highest and the second highest Exports(as % of merchandise exports) of Haiti?
Keep it short and to the point. 1.18. What is the difference between the highest and the second highest Exports(as % of merchandise exports) of Ireland?
Keep it short and to the point. 1.99. What is the difference between the highest and the second highest Exports(as % of merchandise exports) of Liberia?
Your answer should be very brief. 0.46. What is the difference between the highest and the second highest Exports(as % of merchandise exports) in Mauritius?
Offer a very short reply. 1.72. What is the difference between the highest and the lowest Exports(as % of merchandise exports) of Haiti?
Provide a short and direct response. 11.46. What is the difference between the highest and the lowest Exports(as % of merchandise exports) in Ireland?
Give a very brief answer. 9. What is the difference between the highest and the lowest Exports(as % of merchandise exports) of Liberia?
Provide a short and direct response. 1.2. What is the difference between the highest and the lowest Exports(as % of merchandise exports) of Mauritius?
Your answer should be compact. 9.67. 